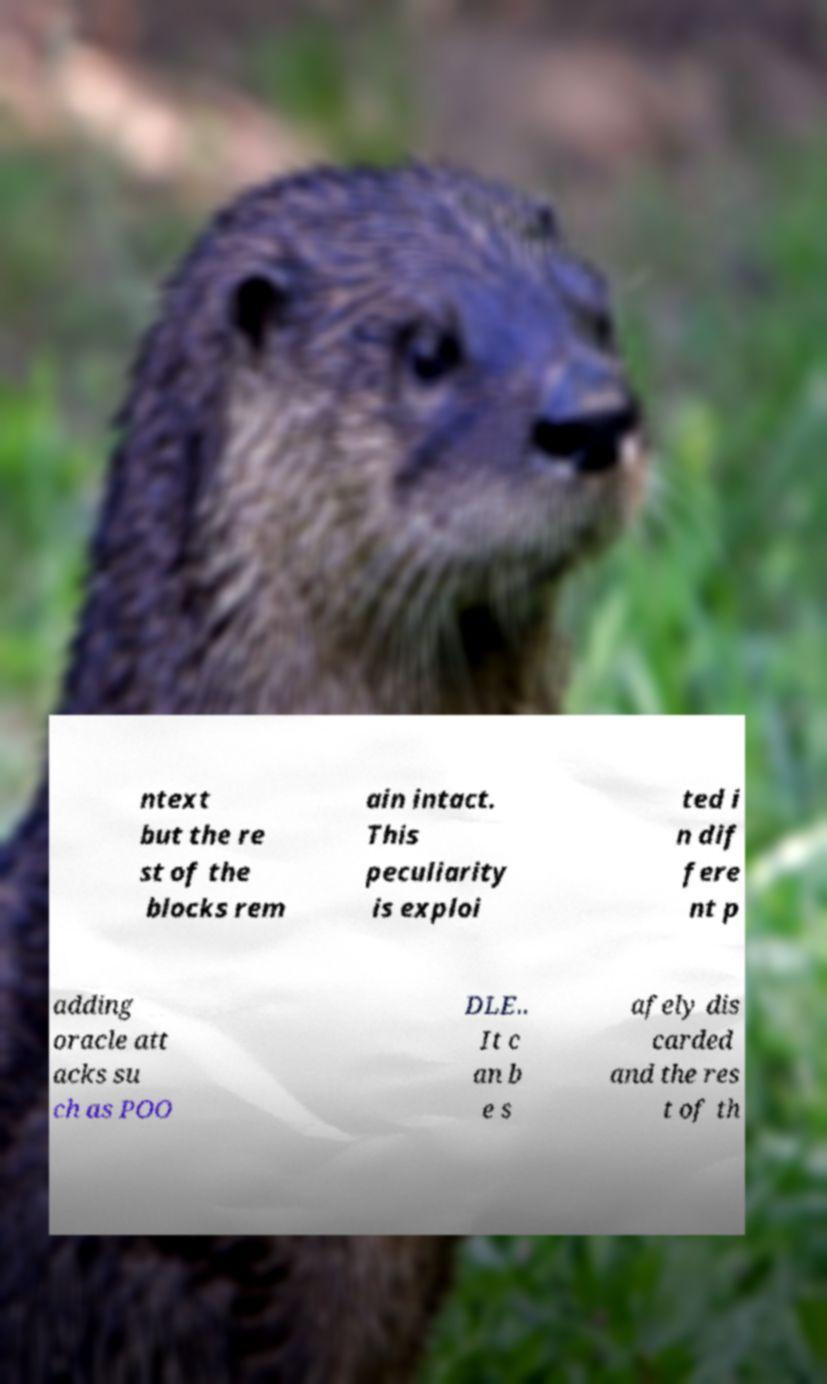There's text embedded in this image that I need extracted. Can you transcribe it verbatim? ntext but the re st of the blocks rem ain intact. This peculiarity is exploi ted i n dif fere nt p adding oracle att acks su ch as POO DLE.. It c an b e s afely dis carded and the res t of th 